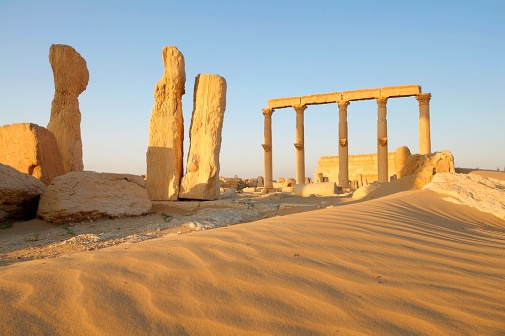What stories do you imagine this temple holds? This ancient temple likely holds countless stories of religious rituals, cultural events, and historical moments. It may have been a place where numerous devotees gathered for worship, offerings, and celebrations. The air would have been filled with chants and music, and the walls echoed with the history of a bygone era. Traders and travelers might have paused here to seek blessings, leaving behind tales of their journeys. Imagine an explorer discovering this temple for the first time. What would they think? An explorer stumbling upon this temple for the first time would be awe-struck by its grandeur and the palpable sense of history. The imposing columns and the remnants of the structure would evoke curiosity and wonder, prompting them to speculate about the people who built it and their way of life. The explorer might note the craftsmanship and try to piece together the temple's original form and purpose. Amid the silent stones, they would feel the weight of time and the stories waiting to be unearthed. What if this place held a hidden treasure? If this temple held a hidden treasure, it might be buried deep beneath the sands or concealed within the intricate stonework. The treasure could include ancient artifacts, gold, jewels, or scrolls with forgotten knowledge. Finding it would involve deciphering ancient scripts, following clues, and possibly navigating secret passageways. Uncovering such a treasure could rewrite history and provide profound insights into the civilization that built this temple. Tell me a short story about the temple. Once upon a time, in the heart of a vast, relentless desert, stood a grand temple. Built by a forgotten civilization, it was a symbol of devotion and artistry. As centuries passed, the temple witnessed the rise and fall of empires, surviving both nature’s fury and human neglect. Now, only a handful of columns remain, standing tall against the golden sands, whispering tales of a glorious past to the desert winds. What's the significance of having such columns in ancient architecture? Columns in ancient architecture were not just structural; they also held symbolic significance. They represented strength, stability, and connection between heaven and earth. Each column was meticulously crafted, often adorned with intricate carvings and sometimes painted with bright colors. These columns, being vertical elements, signified the enduring spirit of the civilization. They were also practical, providing support to roofs and archways and facilitating the creation of open, spacious interiors for gatherings and rituals. 